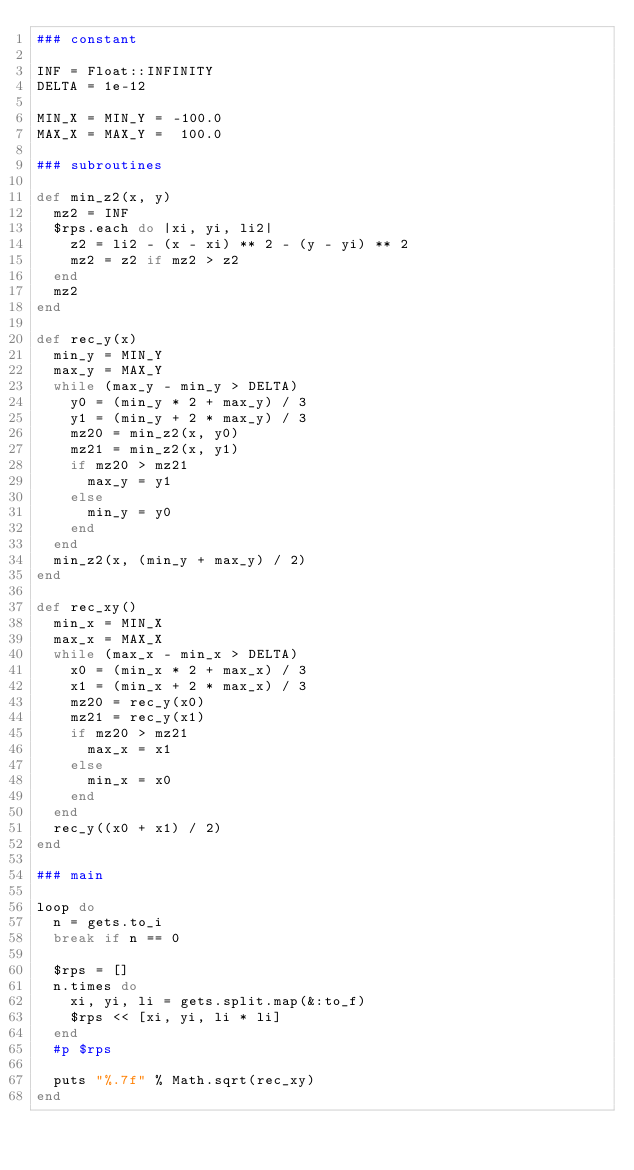Convert code to text. <code><loc_0><loc_0><loc_500><loc_500><_Ruby_>### constant

INF = Float::INFINITY
DELTA = 1e-12

MIN_X = MIN_Y = -100.0
MAX_X = MAX_Y =  100.0

### subroutines

def min_z2(x, y)
  mz2 = INF
  $rps.each do |xi, yi, li2|
    z2 = li2 - (x - xi) ** 2 - (y - yi) ** 2
    mz2 = z2 if mz2 > z2
  end
  mz2
end

def rec_y(x)
  min_y = MIN_Y
  max_y = MAX_Y
  while (max_y - min_y > DELTA)
    y0 = (min_y * 2 + max_y) / 3
    y1 = (min_y + 2 * max_y) / 3
    mz20 = min_z2(x, y0)
    mz21 = min_z2(x, y1)
    if mz20 > mz21
      max_y = y1
    else
      min_y = y0
    end
  end
  min_z2(x, (min_y + max_y) / 2)
end

def rec_xy()
  min_x = MIN_X
  max_x = MAX_X
  while (max_x - min_x > DELTA)
    x0 = (min_x * 2 + max_x) / 3
    x1 = (min_x + 2 * max_x) / 3
    mz20 = rec_y(x0)
    mz21 = rec_y(x1)
    if mz20 > mz21
      max_x = x1
    else
      min_x = x0
    end
  end
  rec_y((x0 + x1) / 2)
end

### main

loop do 
  n = gets.to_i
  break if n == 0

  $rps = []
  n.times do
    xi, yi, li = gets.split.map(&:to_f)
    $rps << [xi, yi, li * li]
  end    
  #p $rps

  puts "%.7f" % Math.sqrt(rec_xy)
end</code> 